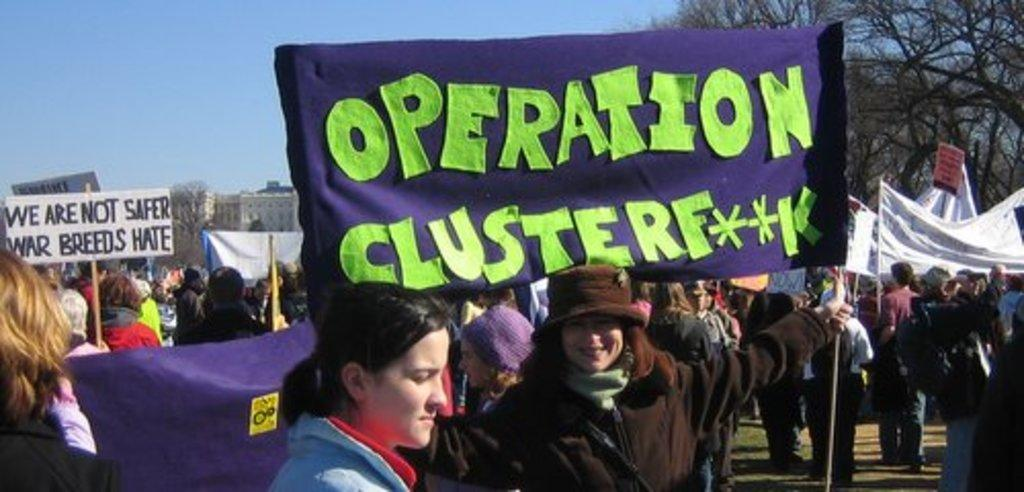Who or what is present in the image? There are people in the image. What are the people holding in the image? The people are holding banners and placards in the image. What can be seen in the background of the image? There are trees and buildings in the background of the image. What word does the tramp say while laughing in the image? There is no tramp or laughter present in the image. 